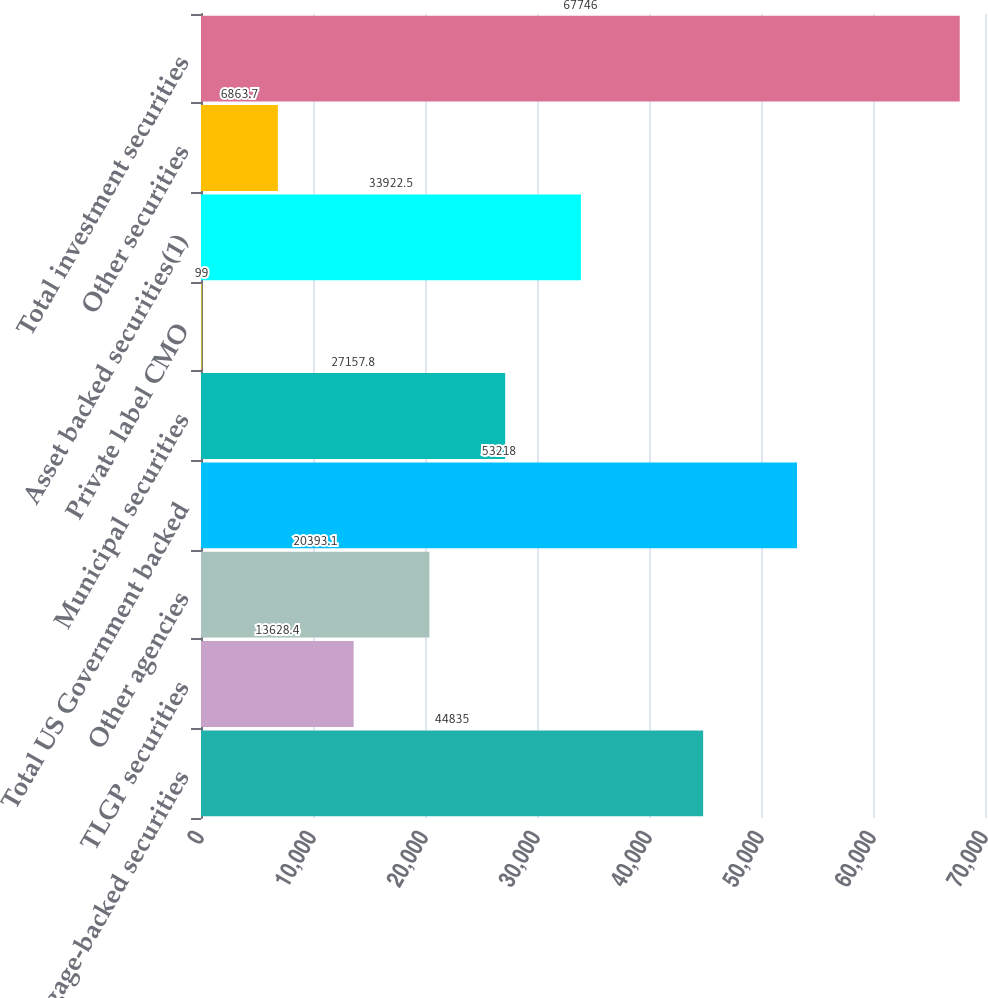Convert chart to OTSL. <chart><loc_0><loc_0><loc_500><loc_500><bar_chart><fcel>Mortgage-backed securities<fcel>TLGP securities<fcel>Other agencies<fcel>Total US Government backed<fcel>Municipal securities<fcel>Private label CMO<fcel>Asset backed securities(1)<fcel>Other securities<fcel>Total investment securities<nl><fcel>44835<fcel>13628.4<fcel>20393.1<fcel>53218<fcel>27157.8<fcel>99<fcel>33922.5<fcel>6863.7<fcel>67746<nl></chart> 